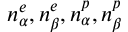Convert formula to latex. <formula><loc_0><loc_0><loc_500><loc_500>n _ { \alpha } ^ { e } , n _ { \beta } ^ { e } , n _ { \alpha } ^ { p } , n _ { \beta } ^ { p }</formula> 